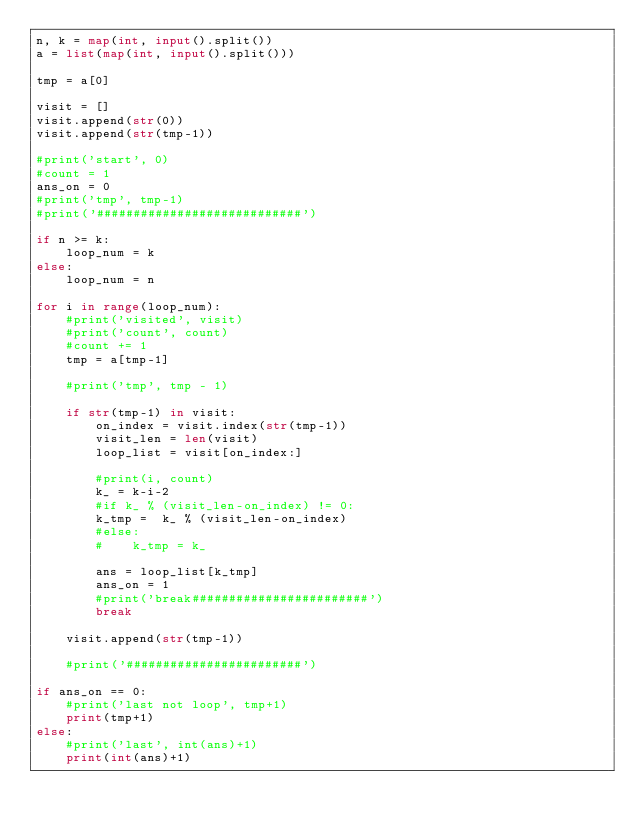Convert code to text. <code><loc_0><loc_0><loc_500><loc_500><_Python_>n, k = map(int, input().split())
a = list(map(int, input().split()))

tmp = a[0]

visit = []
visit.append(str(0))
visit.append(str(tmp-1))

#print('start', 0)
#count = 1
ans_on = 0
#print('tmp', tmp-1)
#print('############################')

if n >= k:
    loop_num = k
else:
    loop_num = n

for i in range(loop_num):
    #print('visited', visit)
    #print('count', count)
    #count += 1
    tmp = a[tmp-1]

    #print('tmp', tmp - 1)

    if str(tmp-1) in visit:
        on_index = visit.index(str(tmp-1))
        visit_len = len(visit)
        loop_list = visit[on_index:]

        #print(i, count)
        k_ = k-i-2
        #if k_ % (visit_len-on_index) != 0:
        k_tmp =  k_ % (visit_len-on_index)
        #else:
        #    k_tmp = k_

        ans = loop_list[k_tmp]
        ans_on = 1
        #print('break########################')
        break

    visit.append(str(tmp-1))

    #print('########################')

if ans_on == 0:
    #print('last not loop', tmp+1)
    print(tmp+1)
else:
    #print('last', int(ans)+1)
    print(int(ans)+1)
</code> 